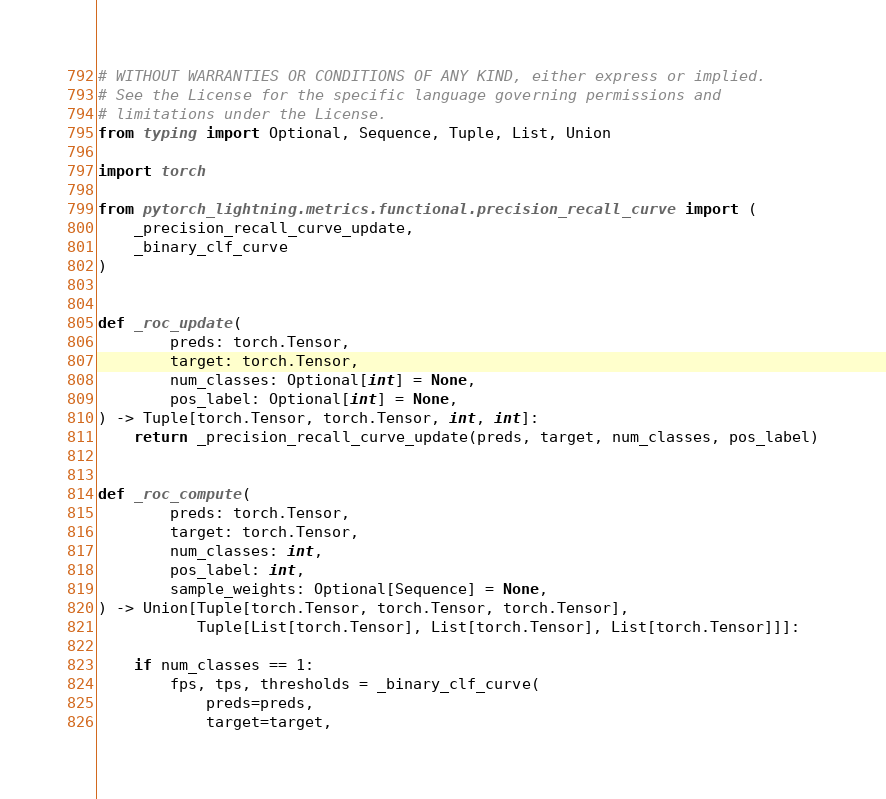<code> <loc_0><loc_0><loc_500><loc_500><_Python_># WITHOUT WARRANTIES OR CONDITIONS OF ANY KIND, either express or implied.
# See the License for the specific language governing permissions and
# limitations under the License.
from typing import Optional, Sequence, Tuple, List, Union

import torch

from pytorch_lightning.metrics.functional.precision_recall_curve import (
    _precision_recall_curve_update,
    _binary_clf_curve
)


def _roc_update(
        preds: torch.Tensor,
        target: torch.Tensor,
        num_classes: Optional[int] = None,
        pos_label: Optional[int] = None,
) -> Tuple[torch.Tensor, torch.Tensor, int, int]:
    return _precision_recall_curve_update(preds, target, num_classes, pos_label)


def _roc_compute(
        preds: torch.Tensor,
        target: torch.Tensor,
        num_classes: int,
        pos_label: int,
        sample_weights: Optional[Sequence] = None,
) -> Union[Tuple[torch.Tensor, torch.Tensor, torch.Tensor],
           Tuple[List[torch.Tensor], List[torch.Tensor], List[torch.Tensor]]]:

    if num_classes == 1:
        fps, tps, thresholds = _binary_clf_curve(
            preds=preds,
            target=target,</code> 